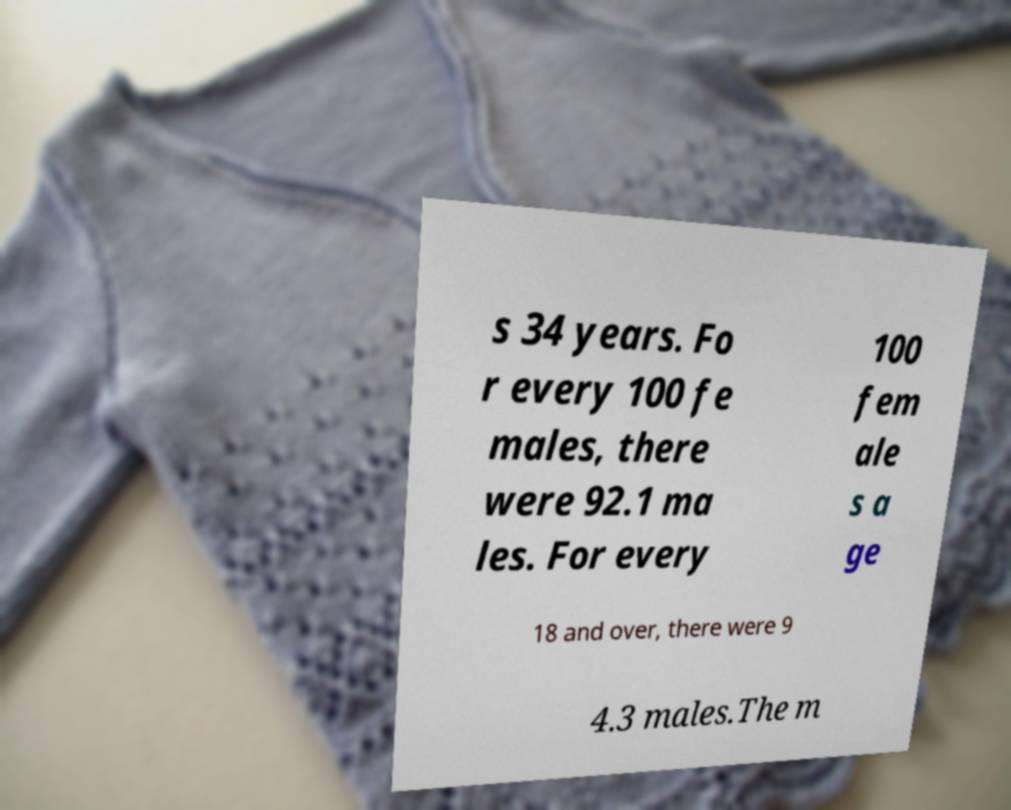Could you assist in decoding the text presented in this image and type it out clearly? s 34 years. Fo r every 100 fe males, there were 92.1 ma les. For every 100 fem ale s a ge 18 and over, there were 9 4.3 males.The m 